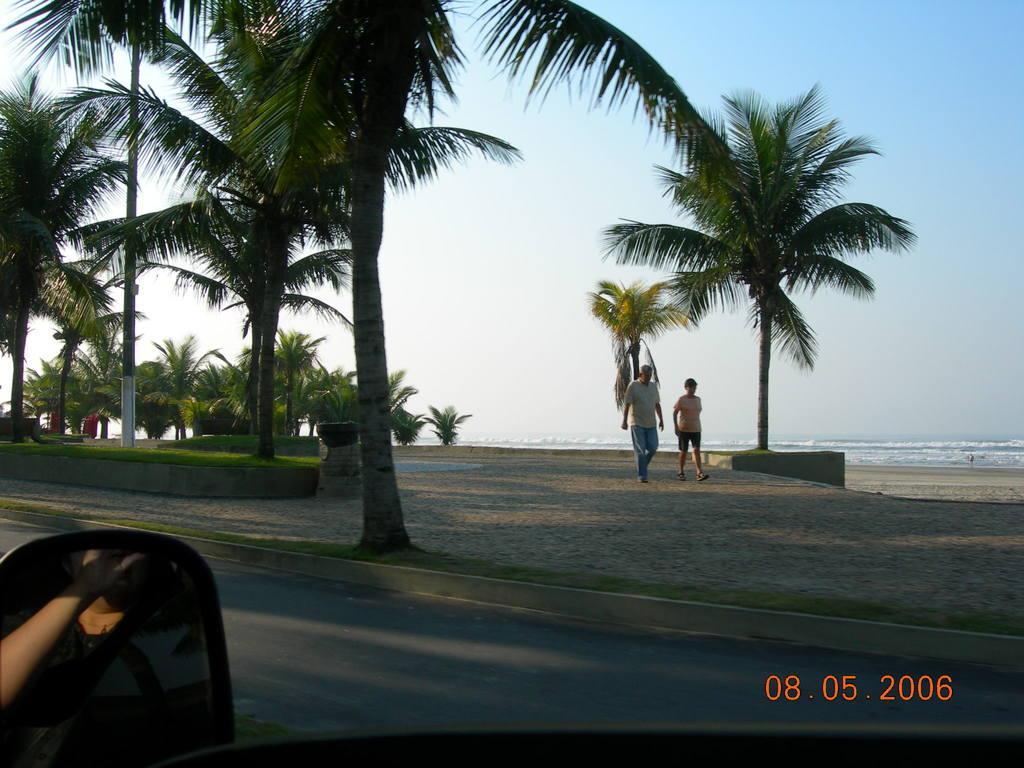In one or two sentences, can you explain what this image depicts? Here we can see two persons are walking on the sand. There are trees, grass, pole, and water. There is a mirror. On the mirror we can see a person. In the background there is sky. 